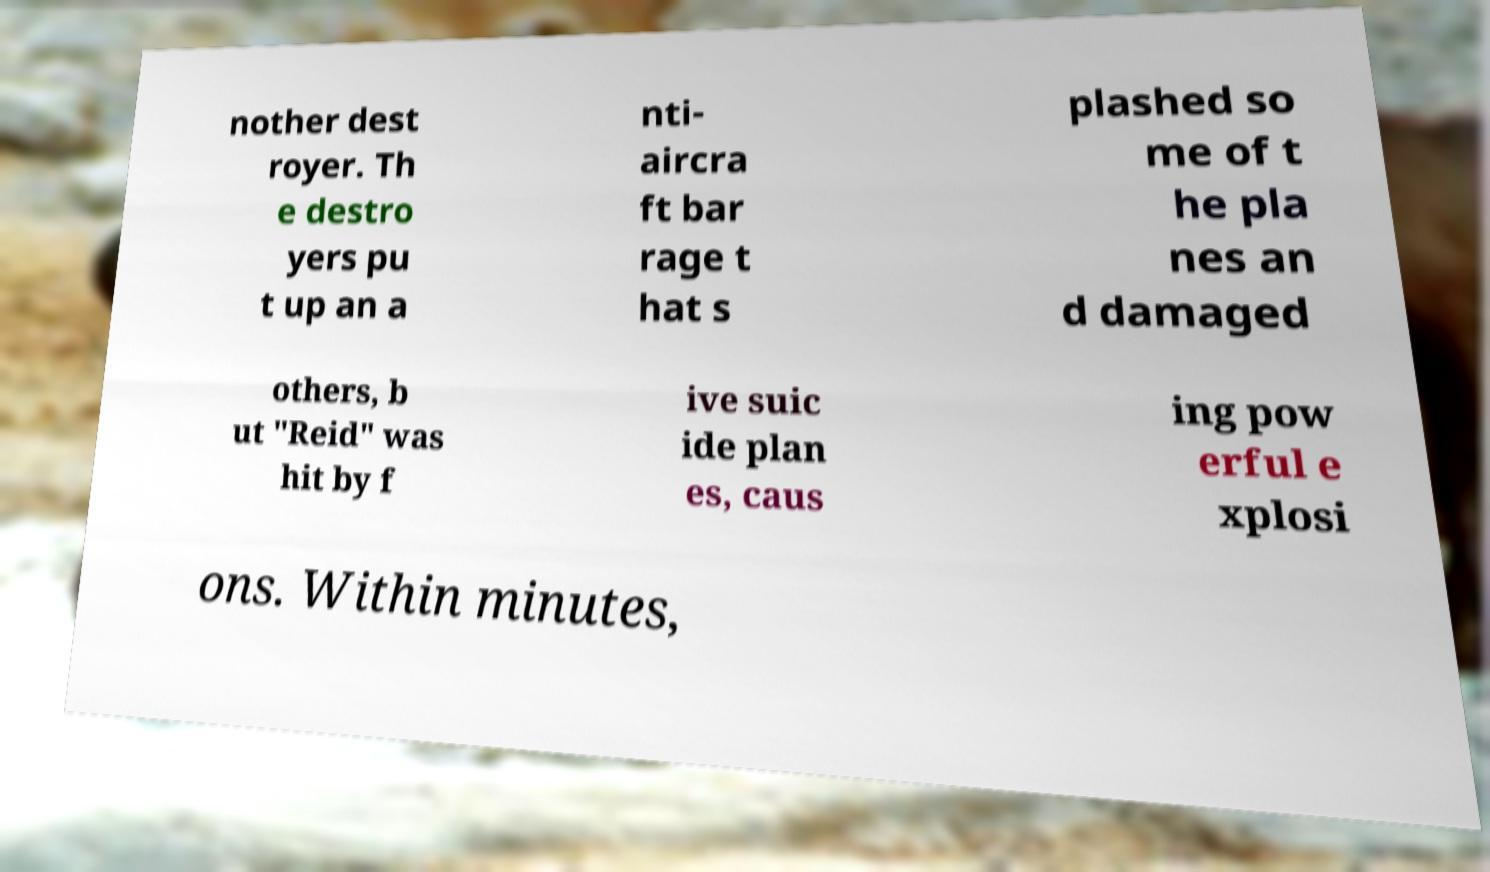What messages or text are displayed in this image? I need them in a readable, typed format. nother dest royer. Th e destro yers pu t up an a nti- aircra ft bar rage t hat s plashed so me of t he pla nes an d damaged others, b ut "Reid" was hit by f ive suic ide plan es, caus ing pow erful e xplosi ons. Within minutes, 